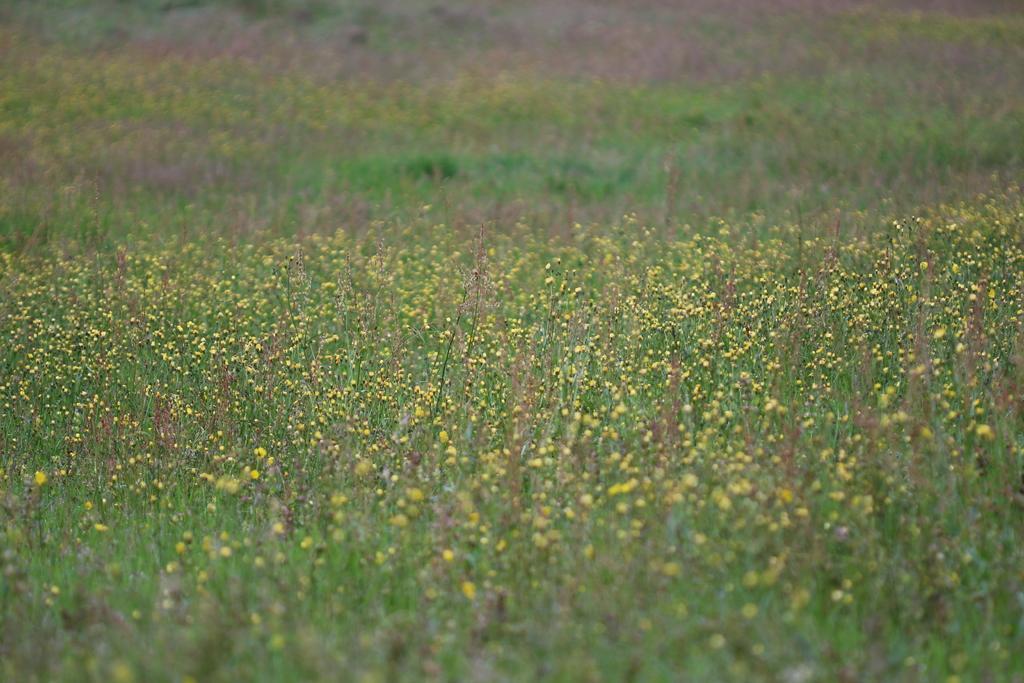In one or two sentences, can you explain what this image depicts? At the bottom of this image, there are plants having flowers. And the background is blurred. 